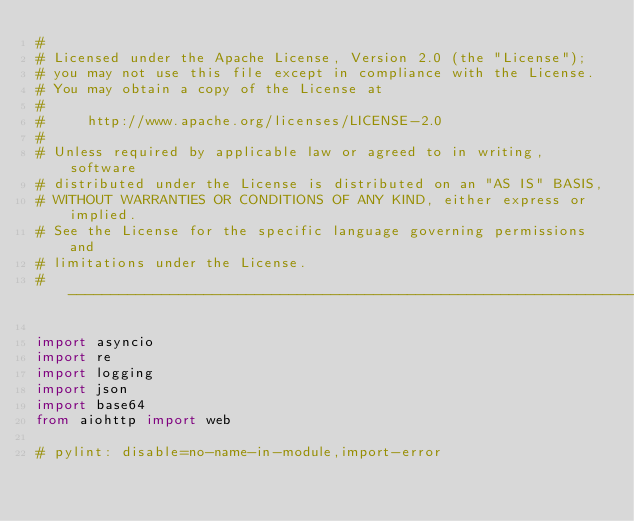<code> <loc_0><loc_0><loc_500><loc_500><_Python_>#
# Licensed under the Apache License, Version 2.0 (the "License");
# you may not use this file except in compliance with the License.
# You may obtain a copy of the License at
#
#     http://www.apache.org/licenses/LICENSE-2.0
#
# Unless required by applicable law or agreed to in writing, software
# distributed under the License is distributed on an "AS IS" BASIS,
# WITHOUT WARRANTIES OR CONDITIONS OF ANY KIND, either express or implied.
# See the License for the specific language governing permissions and
# limitations under the License.
# ------------------------------------------------------------------------------

import asyncio
import re
import logging
import json
import base64
from aiohttp import web

# pylint: disable=no-name-in-module,import-error</code> 